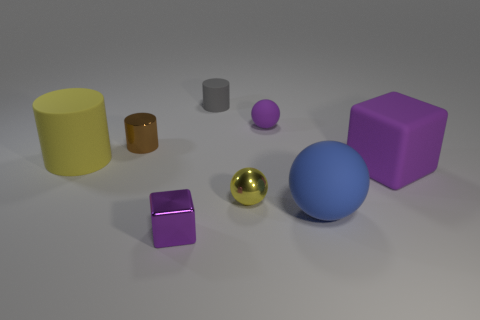Subtract all rubber balls. How many balls are left? 1 Subtract 1 cylinders. How many cylinders are left? 2 Subtract all yellow spheres. How many spheres are left? 2 Subtract 0 blue cylinders. How many objects are left? 8 Subtract all cylinders. How many objects are left? 5 Subtract all green cylinders. Subtract all yellow blocks. How many cylinders are left? 3 Subtract all gray cylinders. How many purple balls are left? 1 Subtract all tiny purple metal blocks. Subtract all big blue rubber objects. How many objects are left? 6 Add 5 small purple metallic things. How many small purple metallic things are left? 6 Add 4 large yellow matte cylinders. How many large yellow matte cylinders exist? 5 